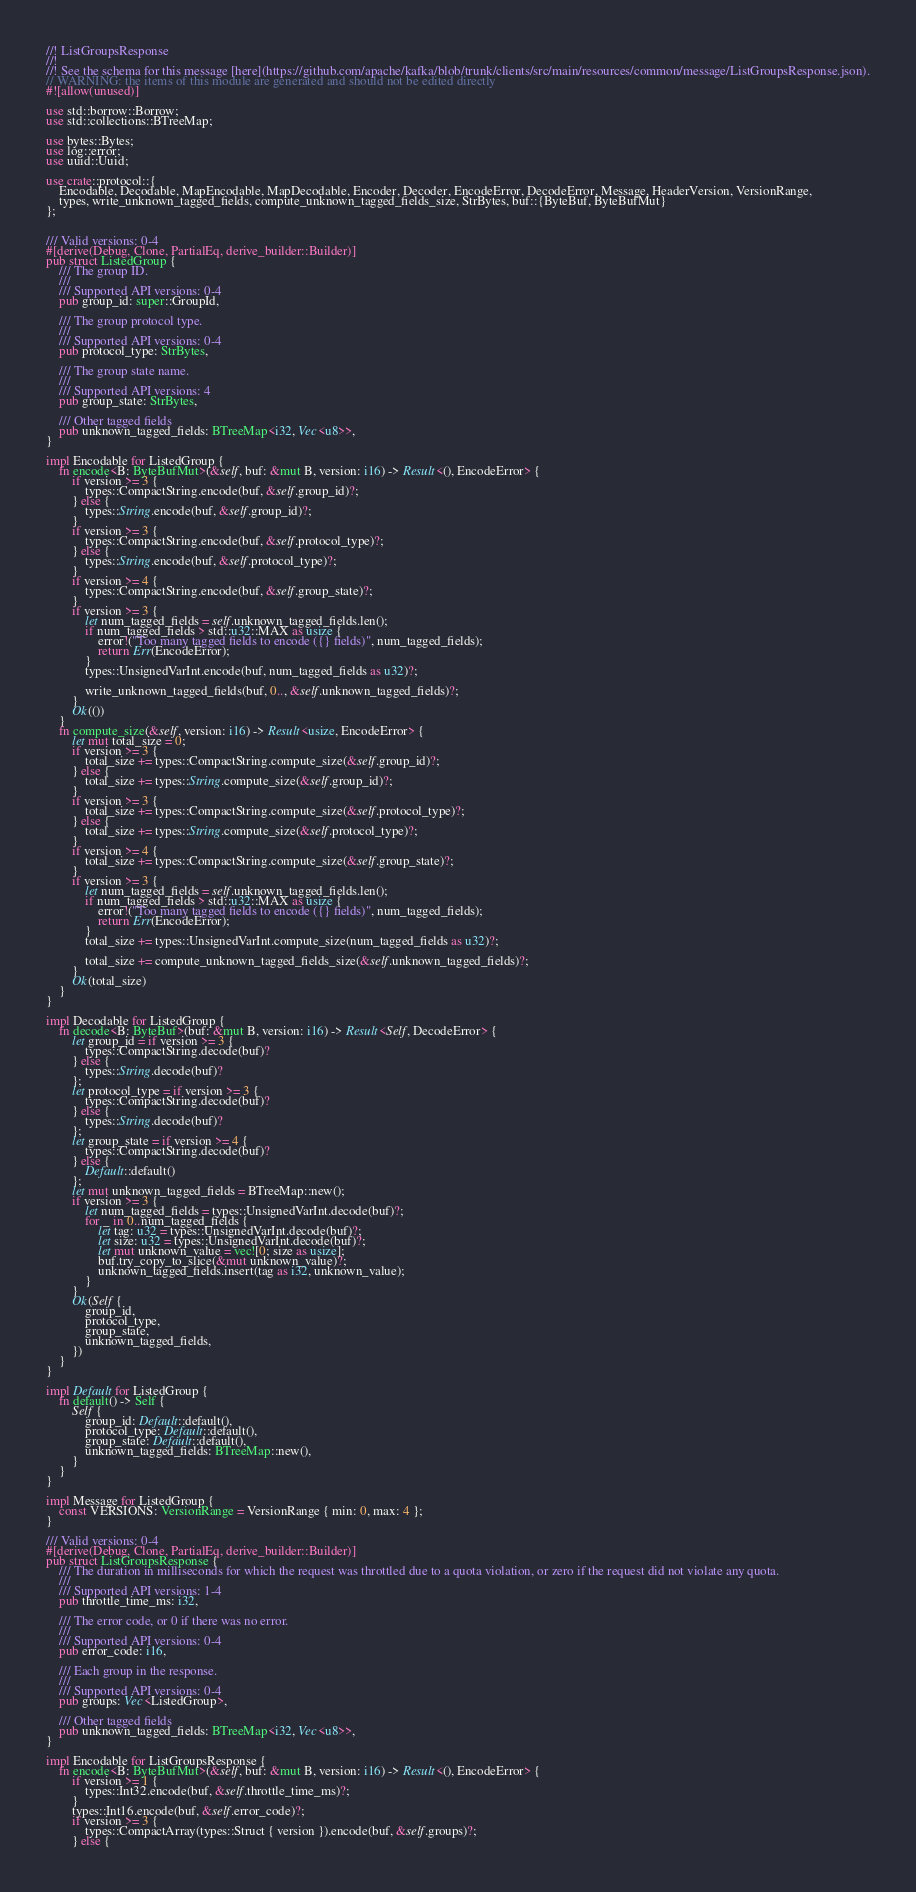Convert code to text. <code><loc_0><loc_0><loc_500><loc_500><_Rust_>//! ListGroupsResponse
//!
//! See the schema for this message [here](https://github.com/apache/kafka/blob/trunk/clients/src/main/resources/common/message/ListGroupsResponse.json).
// WARNING: the items of this module are generated and should not be edited directly
#![allow(unused)]

use std::borrow::Borrow;
use std::collections::BTreeMap;

use bytes::Bytes;
use log::error;
use uuid::Uuid;

use crate::protocol::{
    Encodable, Decodable, MapEncodable, MapDecodable, Encoder, Decoder, EncodeError, DecodeError, Message, HeaderVersion, VersionRange,
    types, write_unknown_tagged_fields, compute_unknown_tagged_fields_size, StrBytes, buf::{ByteBuf, ByteBufMut}
};


/// Valid versions: 0-4
#[derive(Debug, Clone, PartialEq, derive_builder::Builder)]
pub struct ListedGroup {
    /// The group ID.
    /// 
    /// Supported API versions: 0-4
    pub group_id: super::GroupId,

    /// The group protocol type.
    /// 
    /// Supported API versions: 0-4
    pub protocol_type: StrBytes,

    /// The group state name.
    /// 
    /// Supported API versions: 4
    pub group_state: StrBytes,

    /// Other tagged fields
    pub unknown_tagged_fields: BTreeMap<i32, Vec<u8>>,
}

impl Encodable for ListedGroup {
    fn encode<B: ByteBufMut>(&self, buf: &mut B, version: i16) -> Result<(), EncodeError> {
        if version >= 3 {
            types::CompactString.encode(buf, &self.group_id)?;
        } else {
            types::String.encode(buf, &self.group_id)?;
        }
        if version >= 3 {
            types::CompactString.encode(buf, &self.protocol_type)?;
        } else {
            types::String.encode(buf, &self.protocol_type)?;
        }
        if version >= 4 {
            types::CompactString.encode(buf, &self.group_state)?;
        }
        if version >= 3 {
            let num_tagged_fields = self.unknown_tagged_fields.len();
            if num_tagged_fields > std::u32::MAX as usize {
                error!("Too many tagged fields to encode ({} fields)", num_tagged_fields);
                return Err(EncodeError);
            }
            types::UnsignedVarInt.encode(buf, num_tagged_fields as u32)?;

            write_unknown_tagged_fields(buf, 0.., &self.unknown_tagged_fields)?;
        }
        Ok(())
    }
    fn compute_size(&self, version: i16) -> Result<usize, EncodeError> {
        let mut total_size = 0;
        if version >= 3 {
            total_size += types::CompactString.compute_size(&self.group_id)?;
        } else {
            total_size += types::String.compute_size(&self.group_id)?;
        }
        if version >= 3 {
            total_size += types::CompactString.compute_size(&self.protocol_type)?;
        } else {
            total_size += types::String.compute_size(&self.protocol_type)?;
        }
        if version >= 4 {
            total_size += types::CompactString.compute_size(&self.group_state)?;
        }
        if version >= 3 {
            let num_tagged_fields = self.unknown_tagged_fields.len();
            if num_tagged_fields > std::u32::MAX as usize {
                error!("Too many tagged fields to encode ({} fields)", num_tagged_fields);
                return Err(EncodeError);
            }
            total_size += types::UnsignedVarInt.compute_size(num_tagged_fields as u32)?;

            total_size += compute_unknown_tagged_fields_size(&self.unknown_tagged_fields)?;
        }
        Ok(total_size)
    }
}

impl Decodable for ListedGroup {
    fn decode<B: ByteBuf>(buf: &mut B, version: i16) -> Result<Self, DecodeError> {
        let group_id = if version >= 3 {
            types::CompactString.decode(buf)?
        } else {
            types::String.decode(buf)?
        };
        let protocol_type = if version >= 3 {
            types::CompactString.decode(buf)?
        } else {
            types::String.decode(buf)?
        };
        let group_state = if version >= 4 {
            types::CompactString.decode(buf)?
        } else {
            Default::default()
        };
        let mut unknown_tagged_fields = BTreeMap::new();
        if version >= 3 {
            let num_tagged_fields = types::UnsignedVarInt.decode(buf)?;
            for _ in 0..num_tagged_fields {
                let tag: u32 = types::UnsignedVarInt.decode(buf)?;
                let size: u32 = types::UnsignedVarInt.decode(buf)?;
                let mut unknown_value = vec![0; size as usize];
                buf.try_copy_to_slice(&mut unknown_value)?;
                unknown_tagged_fields.insert(tag as i32, unknown_value);
            }
        }
        Ok(Self {
            group_id,
            protocol_type,
            group_state,
            unknown_tagged_fields,
        })
    }
}

impl Default for ListedGroup {
    fn default() -> Self {
        Self {
            group_id: Default::default(),
            protocol_type: Default::default(),
            group_state: Default::default(),
            unknown_tagged_fields: BTreeMap::new(),
        }
    }
}

impl Message for ListedGroup {
    const VERSIONS: VersionRange = VersionRange { min: 0, max: 4 };
}

/// Valid versions: 0-4
#[derive(Debug, Clone, PartialEq, derive_builder::Builder)]
pub struct ListGroupsResponse {
    /// The duration in milliseconds for which the request was throttled due to a quota violation, or zero if the request did not violate any quota.
    /// 
    /// Supported API versions: 1-4
    pub throttle_time_ms: i32,

    /// The error code, or 0 if there was no error.
    /// 
    /// Supported API versions: 0-4
    pub error_code: i16,

    /// Each group in the response.
    /// 
    /// Supported API versions: 0-4
    pub groups: Vec<ListedGroup>,

    /// Other tagged fields
    pub unknown_tagged_fields: BTreeMap<i32, Vec<u8>>,
}

impl Encodable for ListGroupsResponse {
    fn encode<B: ByteBufMut>(&self, buf: &mut B, version: i16) -> Result<(), EncodeError> {
        if version >= 1 {
            types::Int32.encode(buf, &self.throttle_time_ms)?;
        }
        types::Int16.encode(buf, &self.error_code)?;
        if version >= 3 {
            types::CompactArray(types::Struct { version }).encode(buf, &self.groups)?;
        } else {</code> 